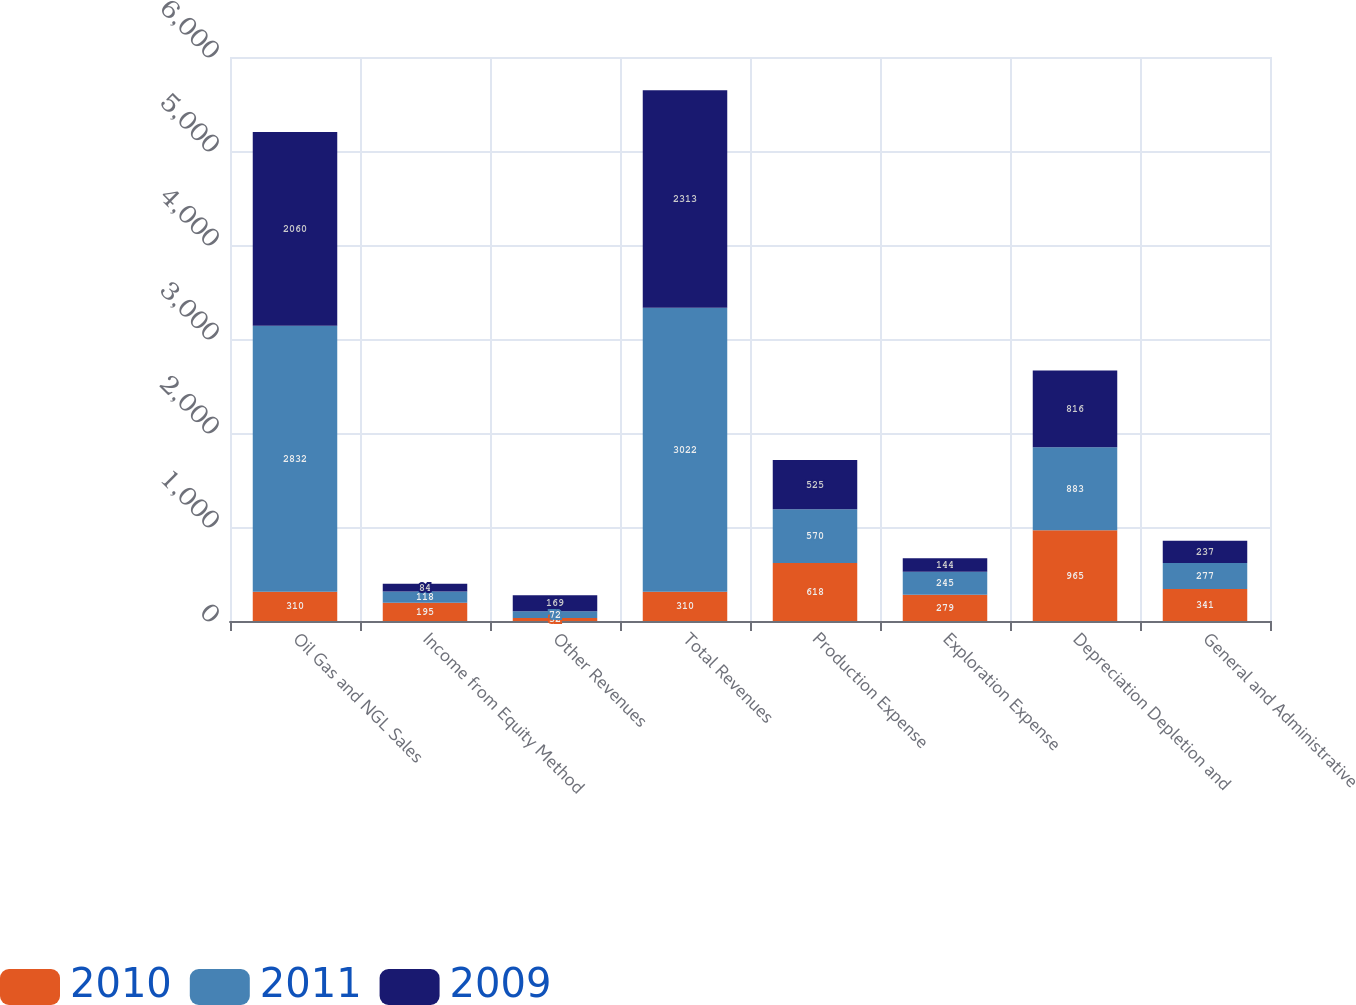Convert chart to OTSL. <chart><loc_0><loc_0><loc_500><loc_500><stacked_bar_chart><ecel><fcel>Oil Gas and NGL Sales<fcel>Income from Equity Method<fcel>Other Revenues<fcel>Total Revenues<fcel>Production Expense<fcel>Exploration Expense<fcel>Depreciation Depletion and<fcel>General and Administrative<nl><fcel>2010<fcel>310<fcel>195<fcel>32<fcel>310<fcel>618<fcel>279<fcel>965<fcel>341<nl><fcel>2011<fcel>2832<fcel>118<fcel>72<fcel>3022<fcel>570<fcel>245<fcel>883<fcel>277<nl><fcel>2009<fcel>2060<fcel>84<fcel>169<fcel>2313<fcel>525<fcel>144<fcel>816<fcel>237<nl></chart> 